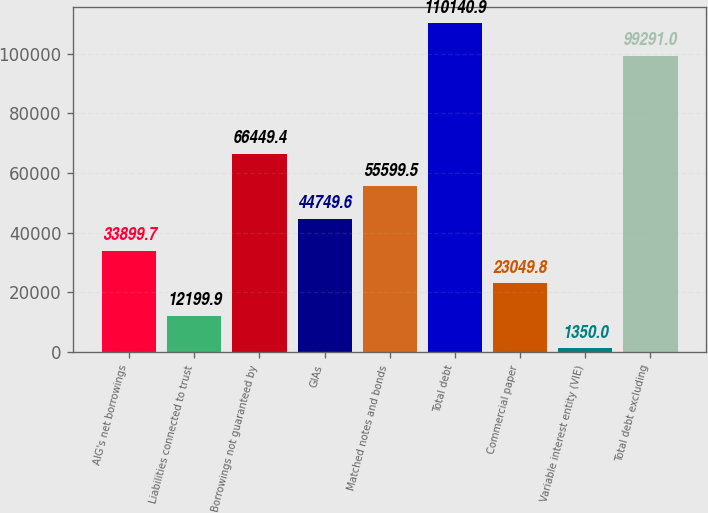Convert chart. <chart><loc_0><loc_0><loc_500><loc_500><bar_chart><fcel>AIG's net borrowings<fcel>Liabilities connected to trust<fcel>Borrowings not guaranteed by<fcel>GIAs<fcel>Matched notes and bonds<fcel>Total debt<fcel>Commercial paper<fcel>Variable interest entity (VIE)<fcel>Total debt excluding<nl><fcel>33899.7<fcel>12199.9<fcel>66449.4<fcel>44749.6<fcel>55599.5<fcel>110141<fcel>23049.8<fcel>1350<fcel>99291<nl></chart> 